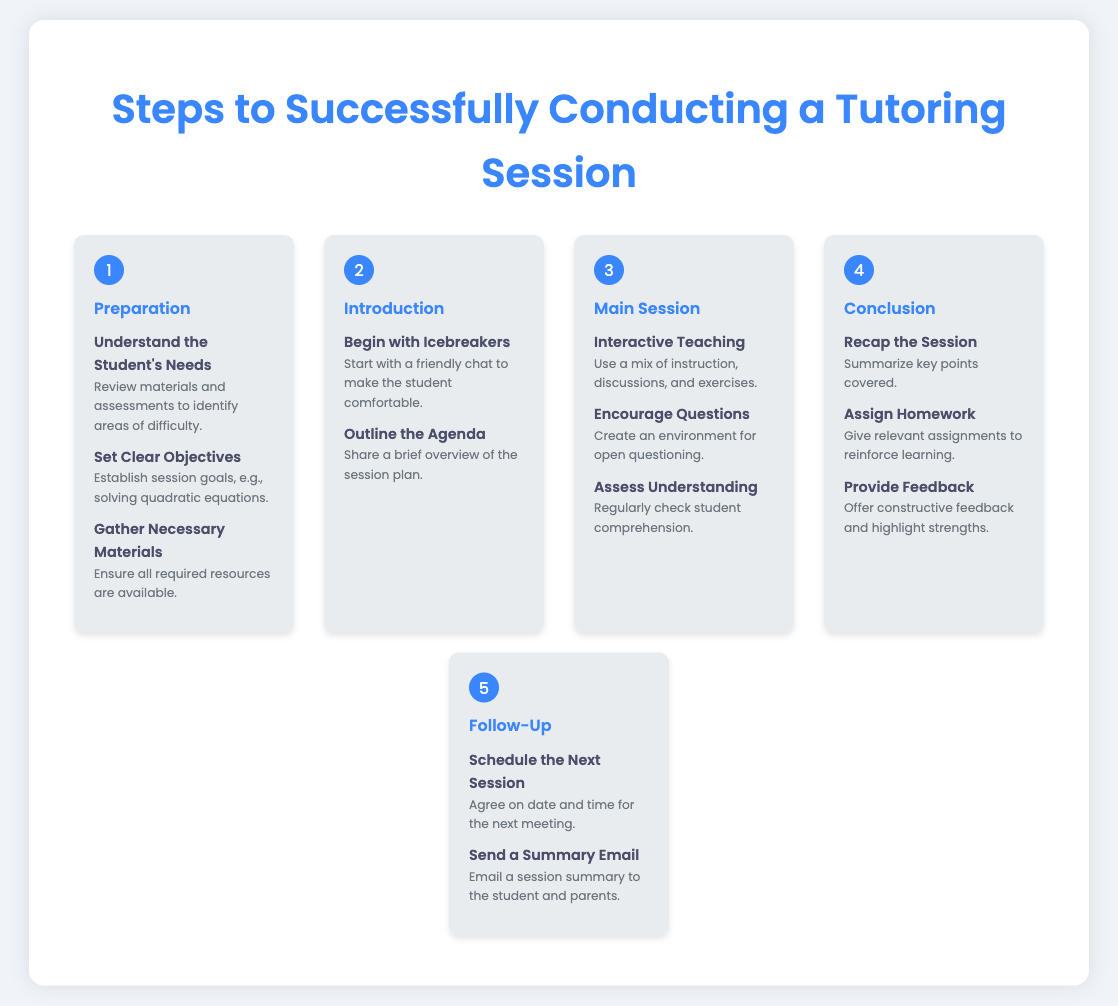What is the first step in conducting a tutoring session? The first step outlined in the document is "Preparation."
Answer: Preparation How many content items are listed in the "Conclusion" step? There are three content items mentioned under the "Conclusion" step.
Answer: 3 What should a tutor do during the "Main Session"? The tutor should engage in "Interactive Teaching."
Answer: Interactive Teaching What is one activity suggested to begin a tutoring session? The document suggests starting with "Icebreakers."
Answer: Icebreakers What is the last step in the tutoring process? The last step outlined in the infographic is "Follow-Up."
Answer: Follow-Up What specific task is included under "Follow-Up"? One task listed is to "Send a Summary Email."
Answer: Send a Summary Email Which step involves outlining the agenda? The step that involves outlining the agenda is "Introduction."
Answer: Introduction How many steps are there in total in the document? The document outlines a total of five steps.
Answer: 5 